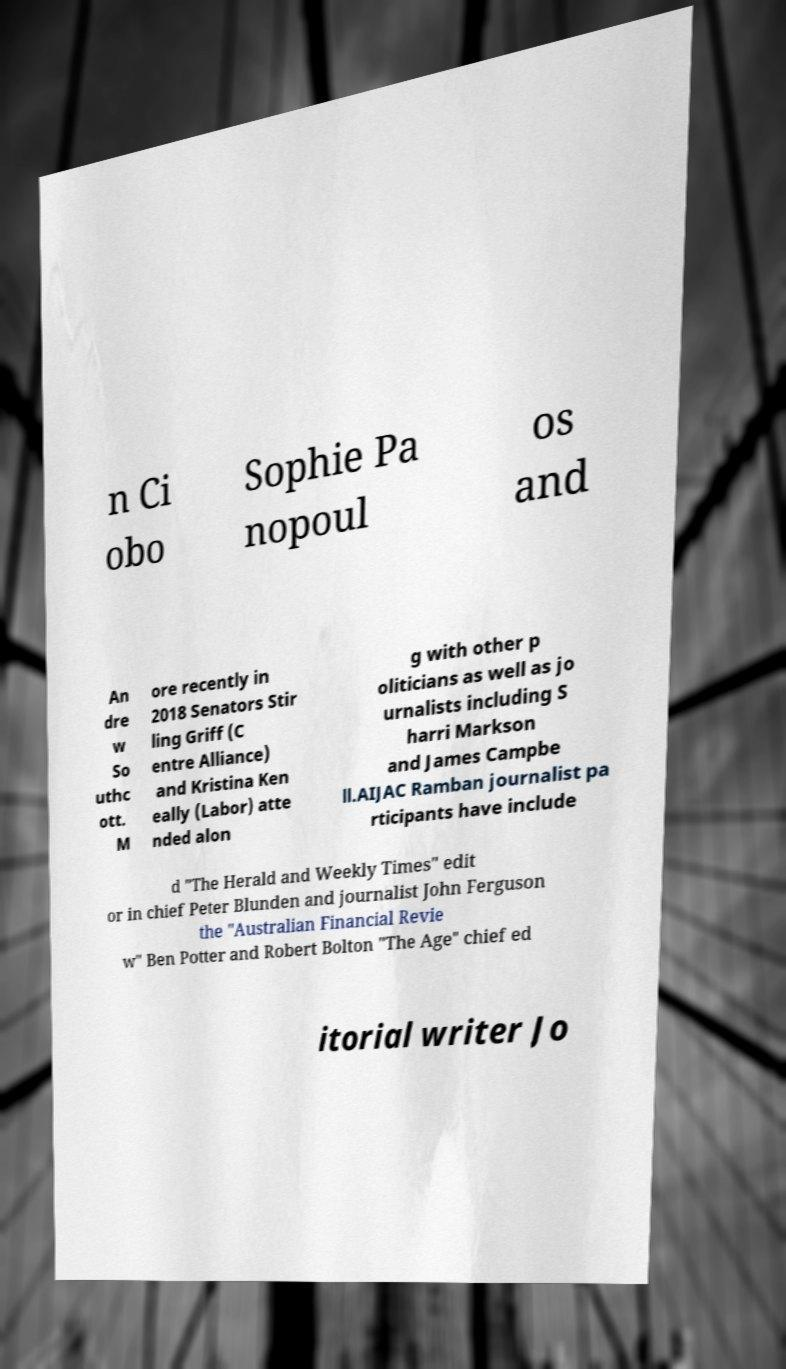What messages or text are displayed in this image? I need them in a readable, typed format. n Ci obo Sophie Pa nopoul os and An dre w So uthc ott. M ore recently in 2018 Senators Stir ling Griff (C entre Alliance) and Kristina Ken eally (Labor) atte nded alon g with other p oliticians as well as jo urnalists including S harri Markson and James Campbe ll.AIJAC Ramban journalist pa rticipants have include d "The Herald and Weekly Times" edit or in chief Peter Blunden and journalist John Ferguson the "Australian Financial Revie w" Ben Potter and Robert Bolton "The Age" chief ed itorial writer Jo 